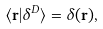<formula> <loc_0><loc_0><loc_500><loc_500>\langle { \mathbf r } | \delta ^ { D } \rangle = \delta ( { \mathbf r } ) ,</formula> 